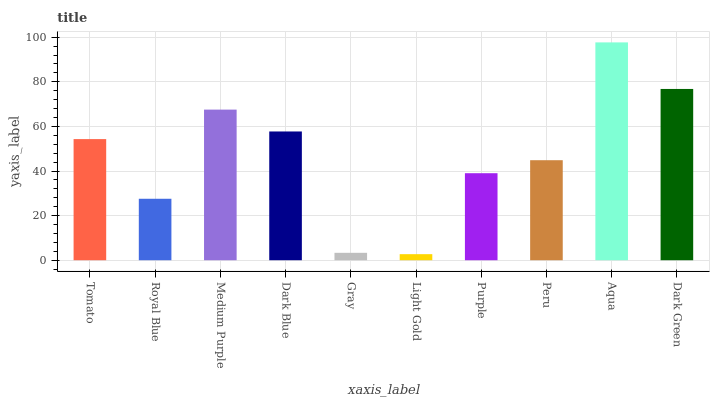Is Light Gold the minimum?
Answer yes or no. Yes. Is Aqua the maximum?
Answer yes or no. Yes. Is Royal Blue the minimum?
Answer yes or no. No. Is Royal Blue the maximum?
Answer yes or no. No. Is Tomato greater than Royal Blue?
Answer yes or no. Yes. Is Royal Blue less than Tomato?
Answer yes or no. Yes. Is Royal Blue greater than Tomato?
Answer yes or no. No. Is Tomato less than Royal Blue?
Answer yes or no. No. Is Tomato the high median?
Answer yes or no. Yes. Is Peru the low median?
Answer yes or no. Yes. Is Aqua the high median?
Answer yes or no. No. Is Aqua the low median?
Answer yes or no. No. 